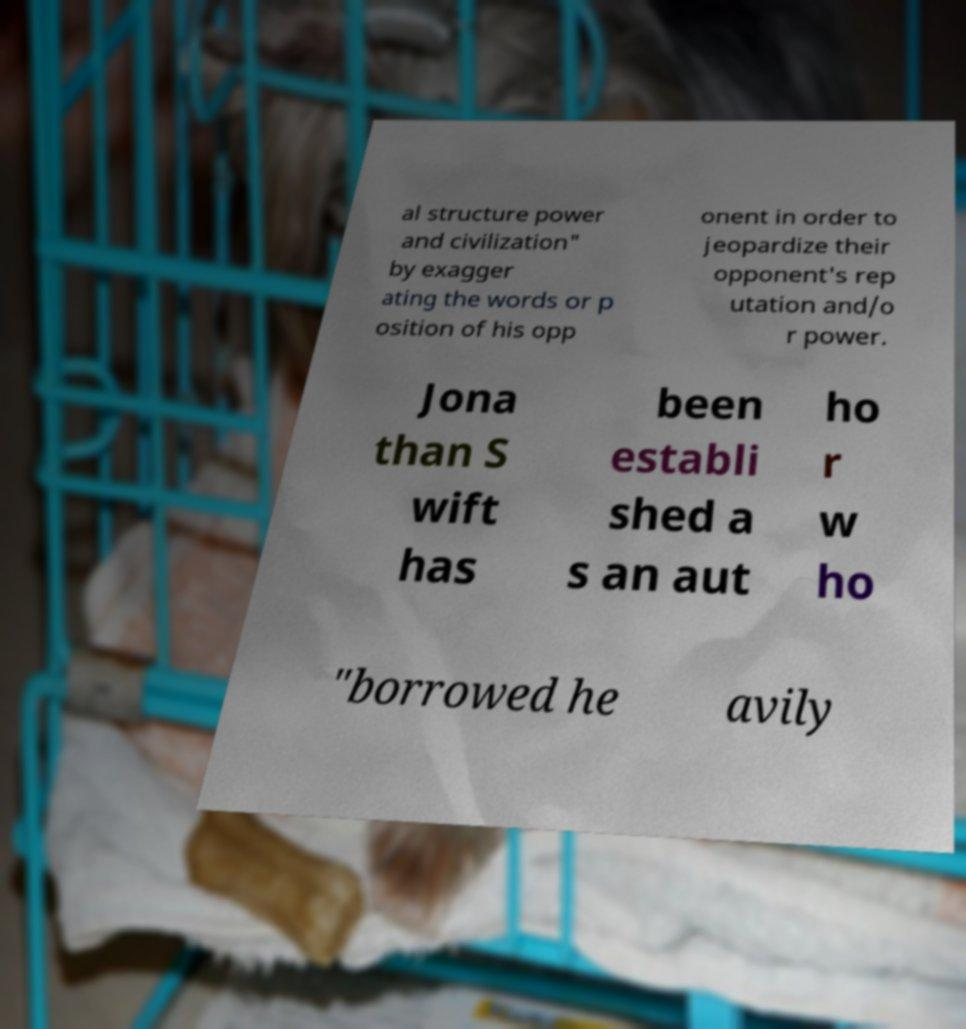There's text embedded in this image that I need extracted. Can you transcribe it verbatim? al structure power and civilization" by exagger ating the words or p osition of his opp onent in order to jeopardize their opponent's rep utation and/o r power. Jona than S wift has been establi shed a s an aut ho r w ho "borrowed he avily 